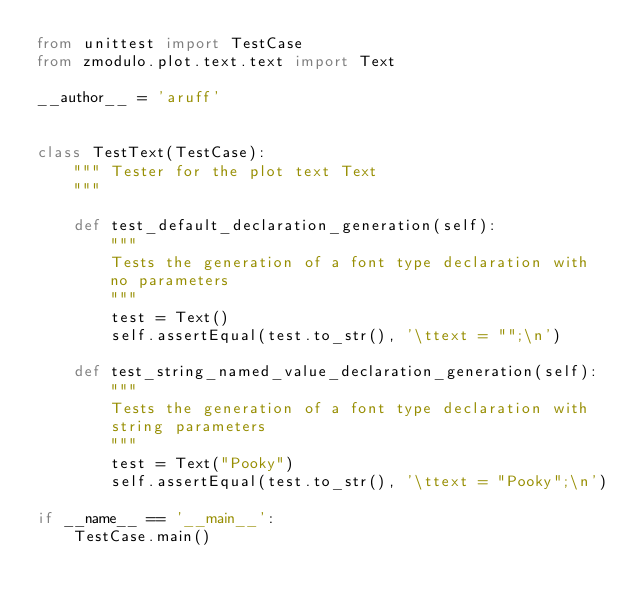<code> <loc_0><loc_0><loc_500><loc_500><_Python_>from unittest import TestCase
from zmodulo.plot.text.text import Text

__author__ = 'aruff'


class TestText(TestCase):
    """ Tester for the plot text Text
    """

    def test_default_declaration_generation(self):
        """
        Tests the generation of a font type declaration with
        no parameters
        """
        test = Text()
        self.assertEqual(test.to_str(), '\ttext = "";\n')

    def test_string_named_value_declaration_generation(self):
        """
        Tests the generation of a font type declaration with
        string parameters
        """
        test = Text("Pooky")
        self.assertEqual(test.to_str(), '\ttext = "Pooky";\n')

if __name__ == '__main__':
    TestCase.main()

</code> 